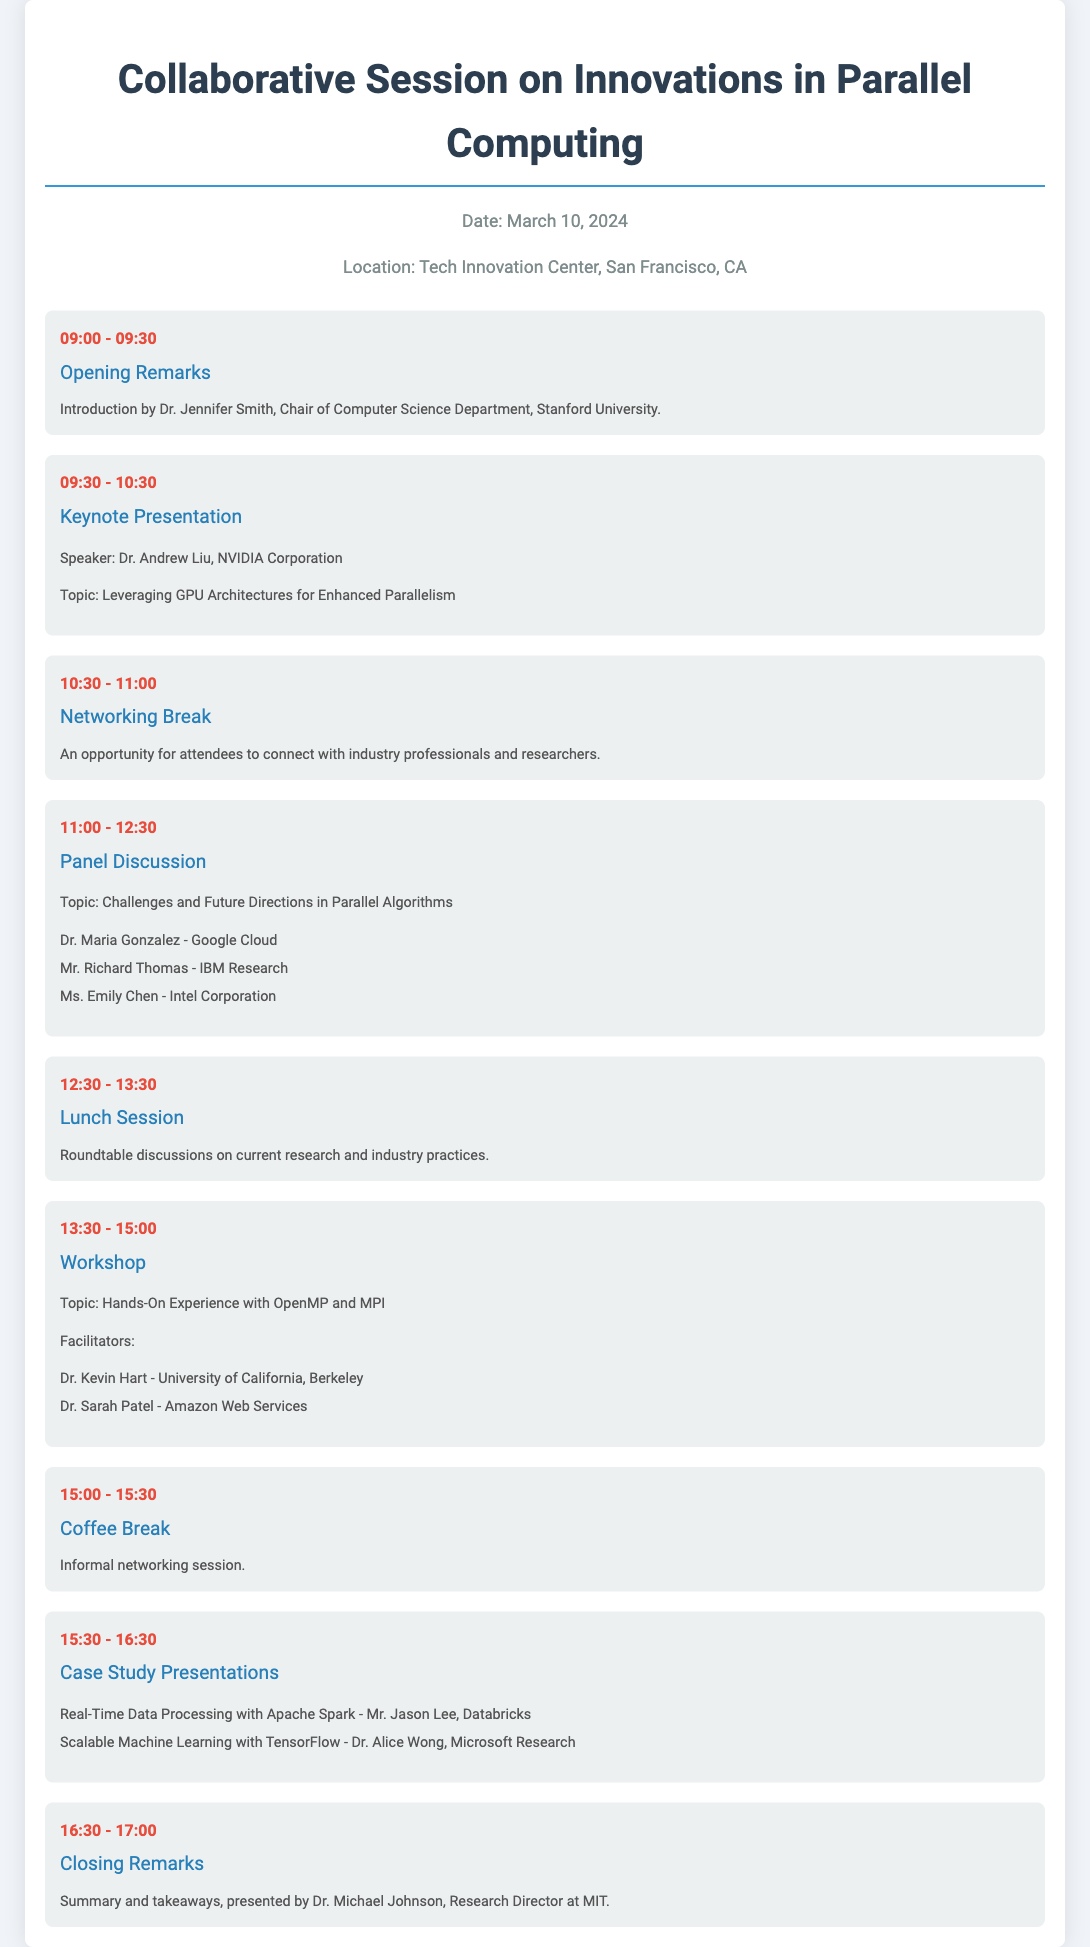What is the date of the event? The date of the event is listed in the information section of the document.
Answer: March 10, 2024 Who is the speaker for the keynote presentation? The speaker for the keynote presentation is mentioned in the schedule.
Answer: Dr. Andrew Liu What is the topic of the panel discussion? The topic of the panel discussion is specified in the details of that session.
Answer: Challenges and Future Directions in Parallel Algorithms How long is the workshop session scheduled for? The duration of the workshop session can be calculated based on the start and end time indicated in the schedule.
Answer: 1.5 hours Which company does Dr. Alice Wong represent? The company representation is given in the details of the case study presentations.
Answer: Microsoft Research What time does the lunch session start? The start time for the lunch session is provided in the schedule.
Answer: 12:30 Who is facilitating the workshop? The facilitators of the workshop are listed in the details of that session.
Answer: Dr. Kevin Hart and Dr. Sarah Patel When are the closing remarks scheduled? The schedule specifies the time allocated for the closing remarks session.
Answer: 16:30 - 17:00 